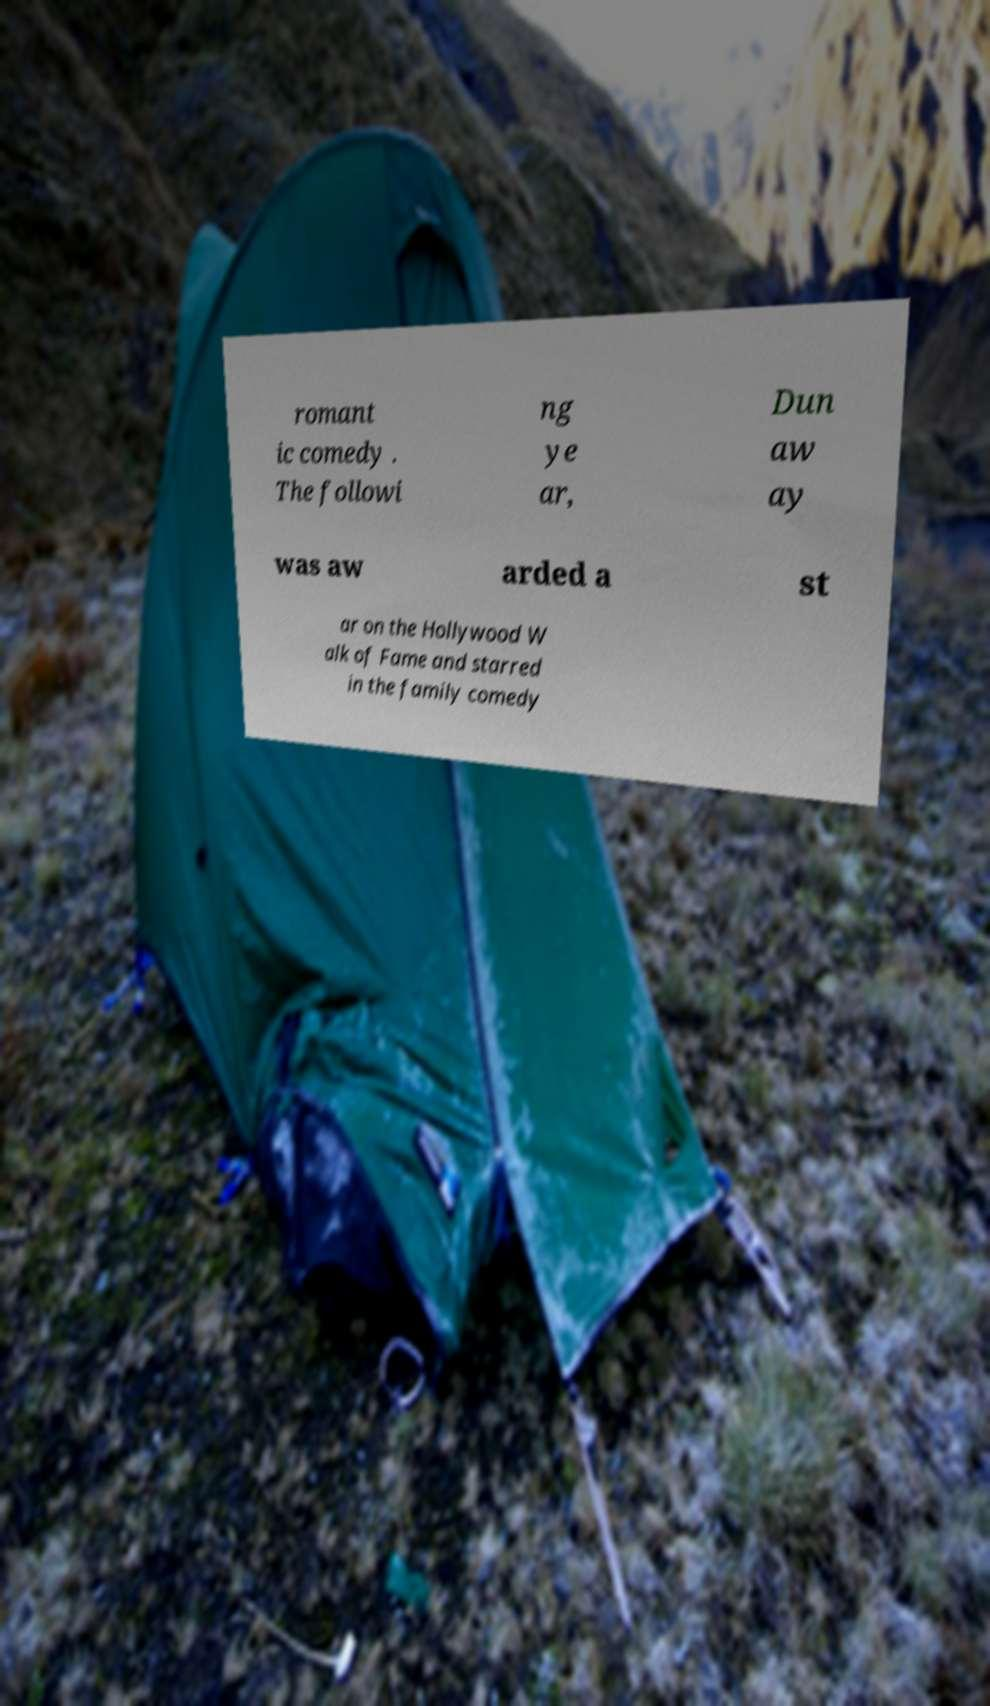What messages or text are displayed in this image? I need them in a readable, typed format. romant ic comedy . The followi ng ye ar, Dun aw ay was aw arded a st ar on the Hollywood W alk of Fame and starred in the family comedy 